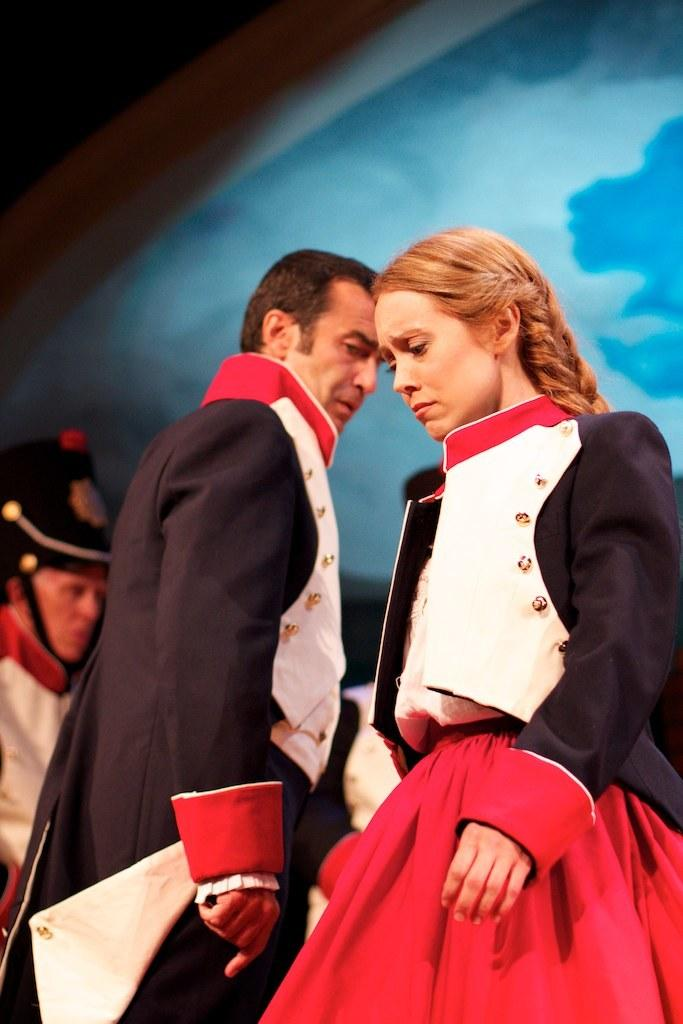How many people are present in the image? There are three people in the image. Can you describe the positions of the people in the image? There is a man and a woman standing, and there is another person standing on the backside, possibly behind the man and woman. What is the gender of the third person in the image? The gender of the third person cannot be determined from the image. How many horses can be seen in the image? There are no horses present in the image. 